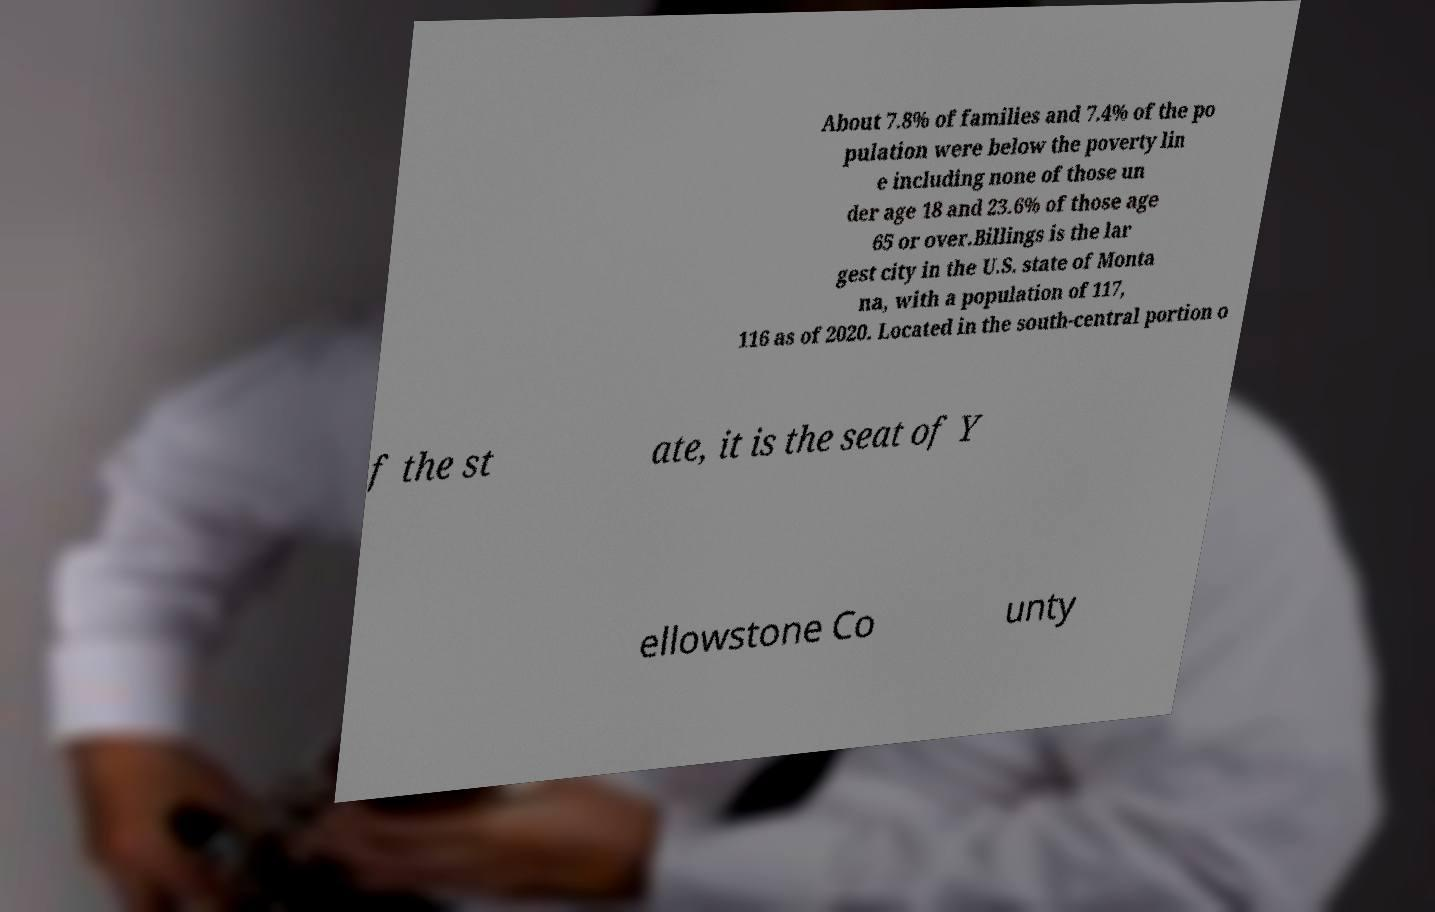Could you assist in decoding the text presented in this image and type it out clearly? About 7.8% of families and 7.4% of the po pulation were below the poverty lin e including none of those un der age 18 and 23.6% of those age 65 or over.Billings is the lar gest city in the U.S. state of Monta na, with a population of 117, 116 as of 2020. Located in the south-central portion o f the st ate, it is the seat of Y ellowstone Co unty 